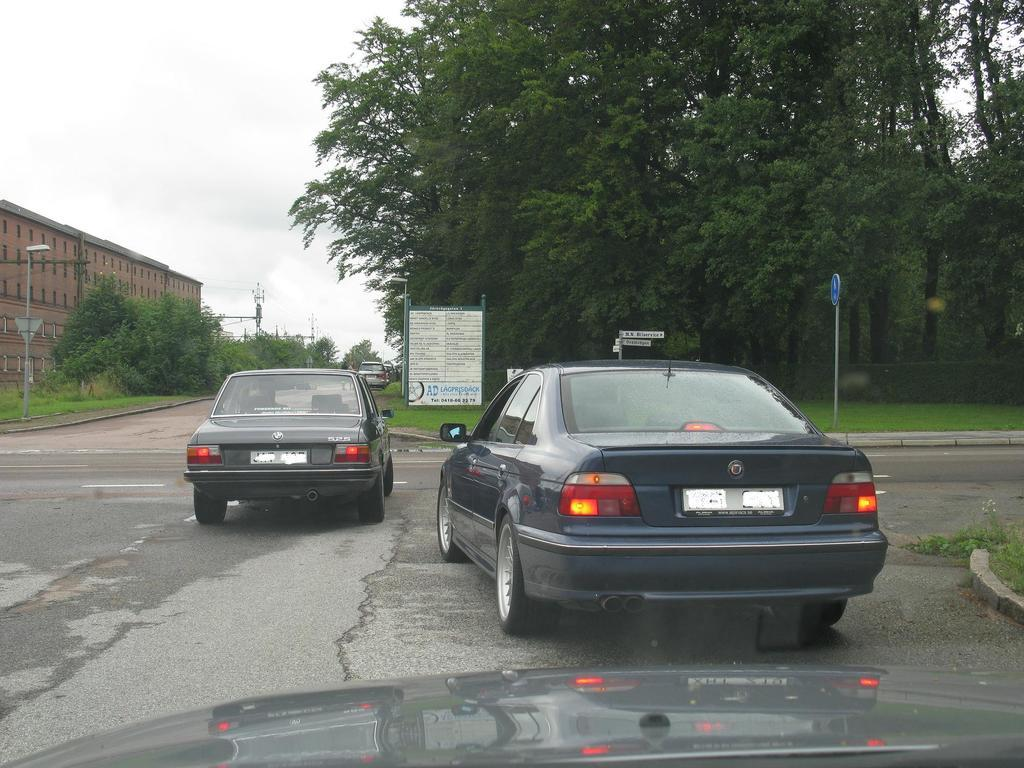What is the primary subject of the image? The primary subject of the image is many cars on the ground. What can be seen on the right side of the image? There are trees on the right side of the image. What type of agreement can be seen taking place between the cars in the image? There is no agreement taking place between the cars in the image; they are simply parked or stationary. 